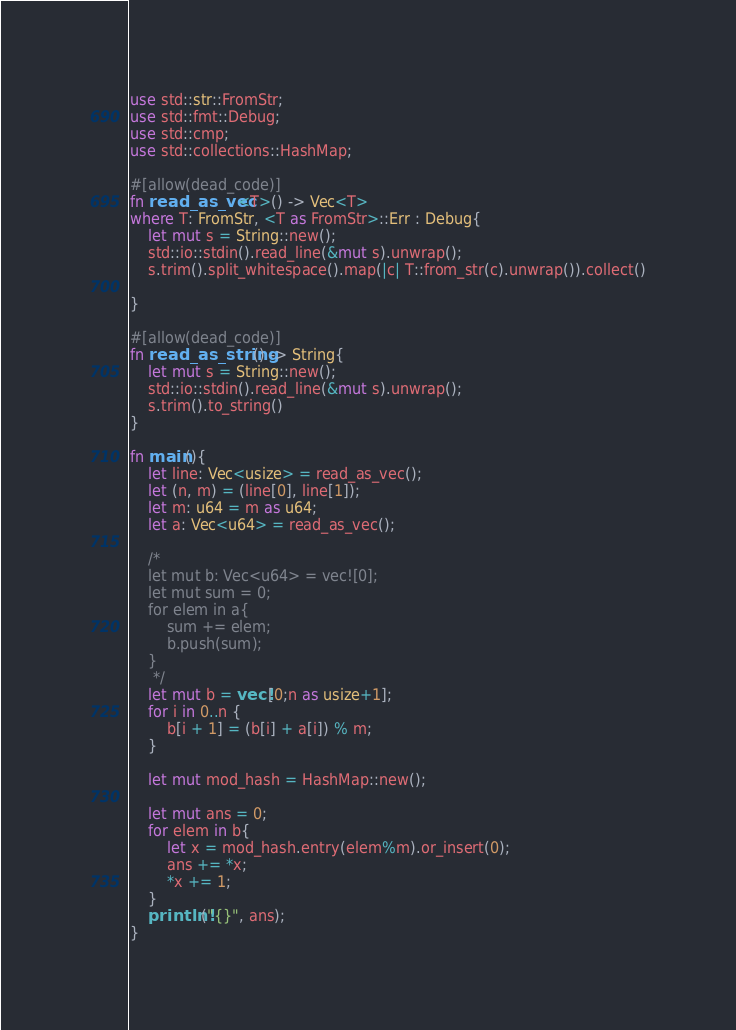Convert code to text. <code><loc_0><loc_0><loc_500><loc_500><_Rust_>use std::str::FromStr;
use std::fmt::Debug;
use std::cmp;
use std::collections::HashMap;

#[allow(dead_code)]
fn read_as_vec<T>() -> Vec<T>
where T: FromStr, <T as FromStr>::Err : Debug{
    let mut s = String::new();
    std::io::stdin().read_line(&mut s).unwrap();
    s.trim().split_whitespace().map(|c| T::from_str(c).unwrap()).collect()

}

#[allow(dead_code)]
fn read_as_string() -> String{
    let mut s = String::new();
    std::io::stdin().read_line(&mut s).unwrap();
    s.trim().to_string()
}

fn main(){
    let line: Vec<usize> = read_as_vec();
    let (n, m) = (line[0], line[1]);
    let m: u64 = m as u64;
    let a: Vec<u64> = read_as_vec();

    /*
    let mut b: Vec<u64> = vec![0];
    let mut sum = 0;
    for elem in a{
        sum += elem;
        b.push(sum);
    }
     */
    let mut b = vec![0;n as usize+1];
    for i in 0..n {
        b[i + 1] = (b[i] + a[i]) % m;
    }

    let mut mod_hash = HashMap::new();

    let mut ans = 0;
    for elem in b{
        let x = mod_hash.entry(elem%m).or_insert(0);
        ans += *x;
        *x += 1;
    }
    println!("{}", ans);
}
</code> 